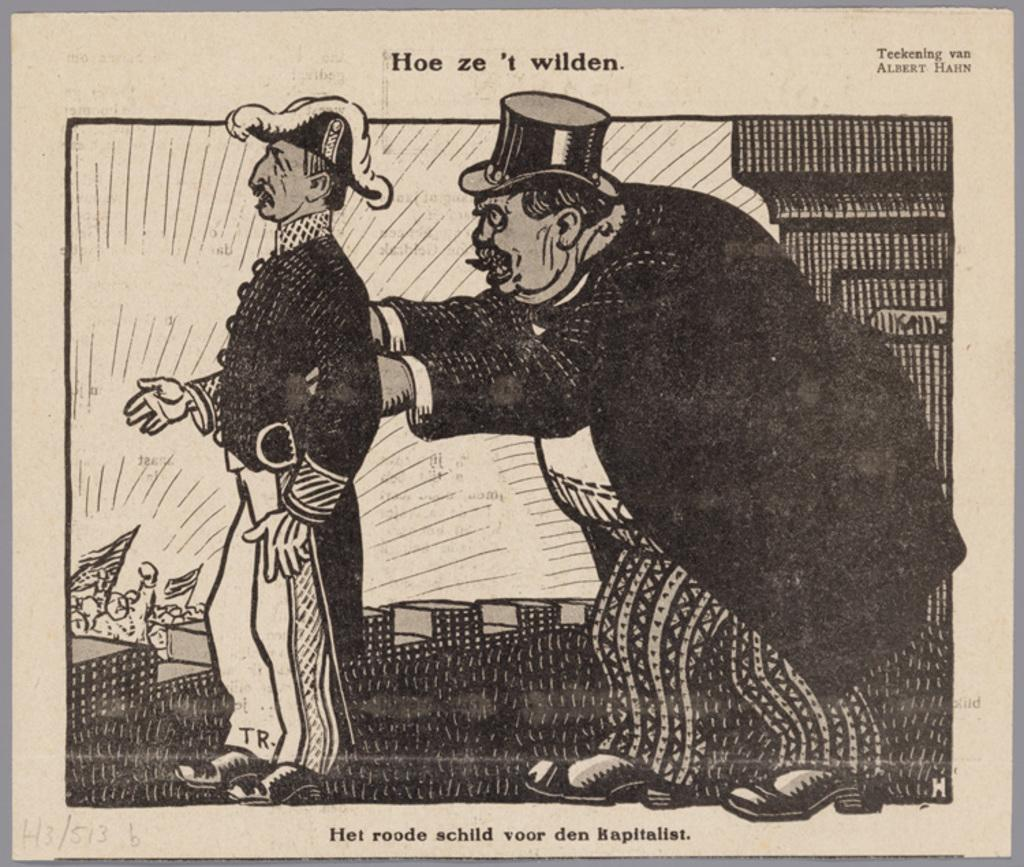What is present in the image that contains visual and written information? There is a poster in the image that contains images and text. Can you describe the images on the poster? The provided facts do not specify the images on the poster, so we cannot describe them. What type of information is conveyed through the text on the poster? The provided facts do not specify the content of the text on the poster, so we cannot describe the information conveyed. How many boats are visible in the image? There are no boats present in the image; it features a poster with images and text. What color is the cap on the bucket in the image? There is no bucket or cap present in the image. 